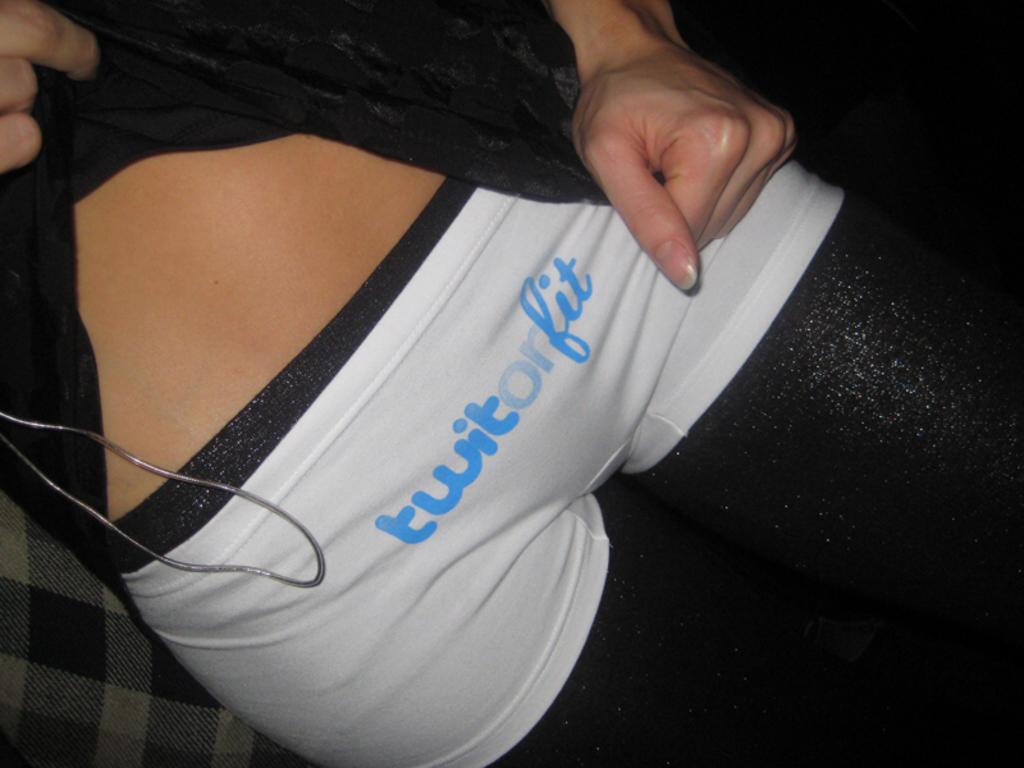What is the brand listed on these undergarments?
Offer a terse response. Twitorfit. What is the cut of the pictured panties?
Your answer should be compact. Unanswerable. 